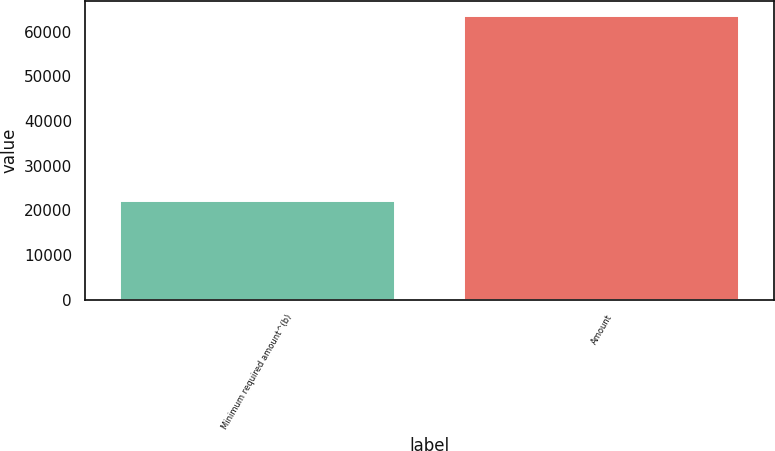<chart> <loc_0><loc_0><loc_500><loc_500><bar_chart><fcel>Minimum required amount^(b)<fcel>Amount<nl><fcel>22076<fcel>63636<nl></chart> 